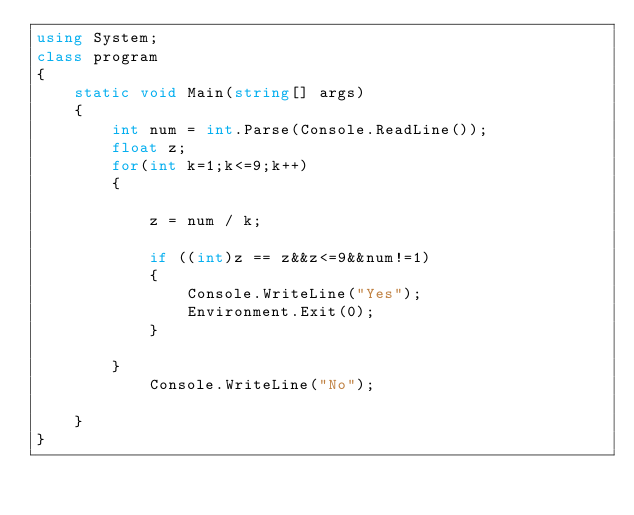<code> <loc_0><loc_0><loc_500><loc_500><_C#_>using System;
class program
{
    static void Main(string[] args)
    {
        int num = int.Parse(Console.ReadLine());
        float z;
        for(int k=1;k<=9;k++)
        {
            
            z = num / k;

            if ((int)z == z&&z<=9&&num!=1)
            {
                Console.WriteLine("Yes");
                Environment.Exit(0);
            }

        }
            Console.WriteLine("No");
        
    }
}
</code> 